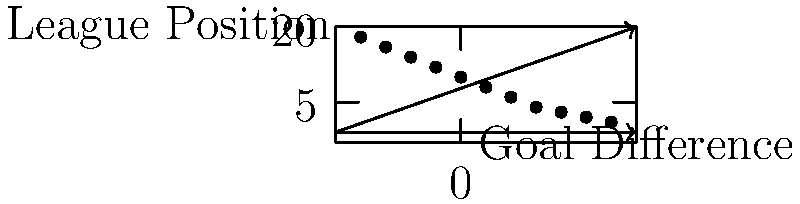Based on the scatter plot showing Newcastle United's goal difference and final league position over several seasons, what can be inferred about the relationship between these two variables? To analyze the relationship between Newcastle United's goal difference and final league position, let's examine the scatter plot step-by-step:

1. Observe the overall trend: As we move from left to right (increasing goal difference), the points generally move downwards (lower league position numbers, which indicate higher standings).

2. Direction of relationship: This downward trend indicates a negative correlation between goal difference and league position number. Remember that a lower position number means a higher finish in the league table.

3. Strength of relationship: The points follow a fairly consistent pattern without much scatter, suggesting a strong correlation.

4. Linearity: The relationship appears to be roughly linear, although there's a slight curve visible.

5. Outliers: There don't appear to be any significant outliers that deviate from the general trend.

6. Interpretation: As Newcastle United's goal difference improves (becomes more positive), their final league position tends to improve (move closer to 1st place).

7. Causality: While correlation doesn't imply causation, in football, a better goal difference often contributes to a higher league position due to the nature of how points are awarded.

Given these observations, we can infer that there is a strong negative correlation between goal difference and league position number, which translates to a positive relationship between goal difference and performance in the league table.
Answer: Strong negative correlation between goal difference and league position number, indicating better performance with improved goal difference. 